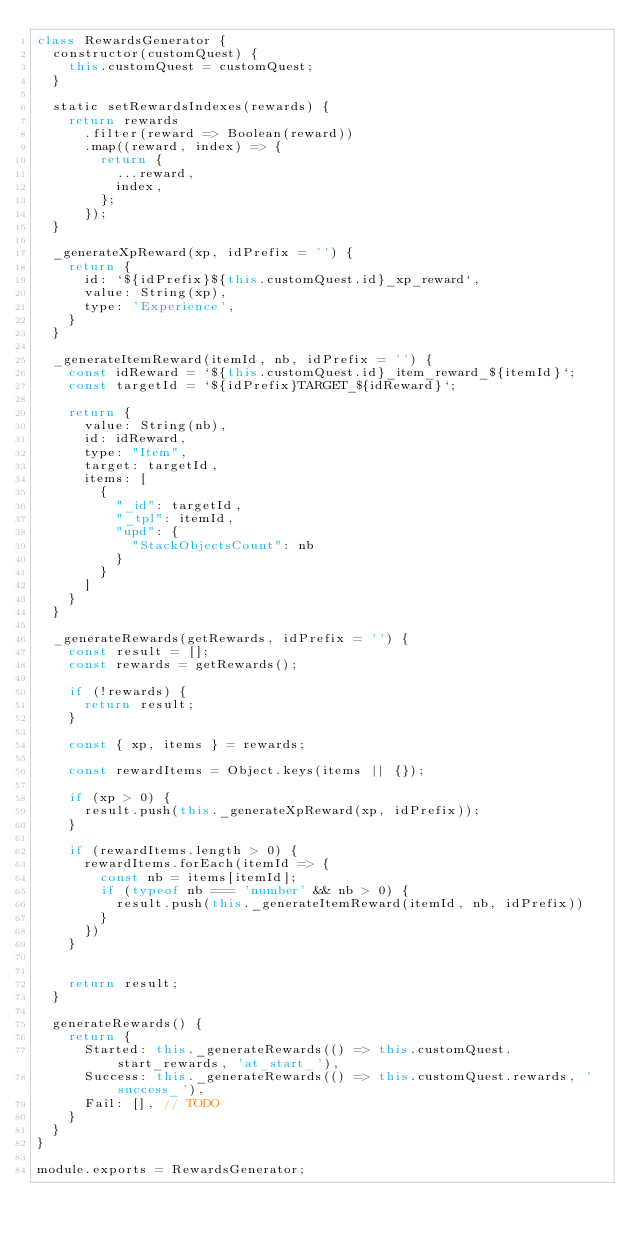Convert code to text. <code><loc_0><loc_0><loc_500><loc_500><_JavaScript_>class RewardsGenerator {
  constructor(customQuest) {
    this.customQuest = customQuest;
  }

  static setRewardsIndexes(rewards) {
    return rewards
      .filter(reward => Boolean(reward))
      .map((reward, index) => {
        return {
          ...reward,
          index,
        };
      });
  }

  _generateXpReward(xp, idPrefix = '') {
    return {
      id: `${idPrefix}${this.customQuest.id}_xp_reward`,
      value: String(xp),
      type: 'Experience',
    }
  }

  _generateItemReward(itemId, nb, idPrefix = '') {
    const idReward = `${this.customQuest.id}_item_reward_${itemId}`;
    const targetId = `${idPrefix}TARGET_${idReward}`;

    return {
      value: String(nb),
      id: idReward,
      type: "Item",
      target: targetId,
      items: [
        {
          "_id": targetId,
          "_tpl": itemId,
          "upd": {
            "StackObjectsCount": nb
          }
        }
      ]
    }
  }

  _generateRewards(getRewards, idPrefix = '') {
    const result = [];
    const rewards = getRewards();

    if (!rewards) {
      return result;
    }

    const { xp, items } = rewards;

    const rewardItems = Object.keys(items || {});

    if (xp > 0) {
      result.push(this._generateXpReward(xp, idPrefix));
    }

    if (rewardItems.length > 0) {
      rewardItems.forEach(itemId => {
        const nb = items[itemId];
        if (typeof nb === 'number' && nb > 0) {
          result.push(this._generateItemReward(itemId, nb, idPrefix))
        }
      })
    }


    return result;
  }

  generateRewards() {
    return {
      Started: this._generateRewards(() => this.customQuest.start_rewards, 'at_start_'),
      Success: this._generateRewards(() => this.customQuest.rewards, 'success_'),
      Fail: [], // TODO
    }
  }
}

module.exports = RewardsGenerator;</code> 